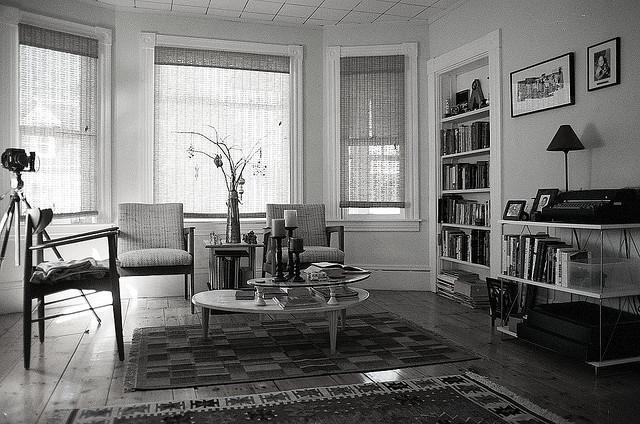What is the camera on the left setup on?
Pick the correct solution from the four options below to address the question.
Options: Selfie stick, table, tripod, mixer. Tripod. 